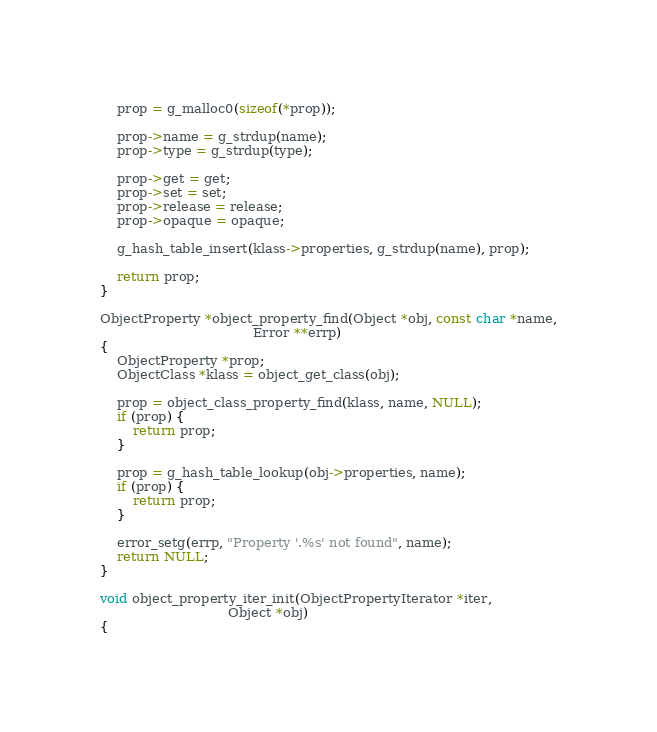<code> <loc_0><loc_0><loc_500><loc_500><_C_>
    prop = g_malloc0(sizeof(*prop));

    prop->name = g_strdup(name);
    prop->type = g_strdup(type);

    prop->get = get;
    prop->set = set;
    prop->release = release;
    prop->opaque = opaque;

    g_hash_table_insert(klass->properties, g_strdup(name), prop);

    return prop;
}

ObjectProperty *object_property_find(Object *obj, const char *name,
                                     Error **errp)
{
    ObjectProperty *prop;
    ObjectClass *klass = object_get_class(obj);

    prop = object_class_property_find(klass, name, NULL);
    if (prop) {
        return prop;
    }

    prop = g_hash_table_lookup(obj->properties, name);
    if (prop) {
        return prop;
    }

    error_setg(errp, "Property '.%s' not found", name);
    return NULL;
}

void object_property_iter_init(ObjectPropertyIterator *iter,
                               Object *obj)
{</code> 